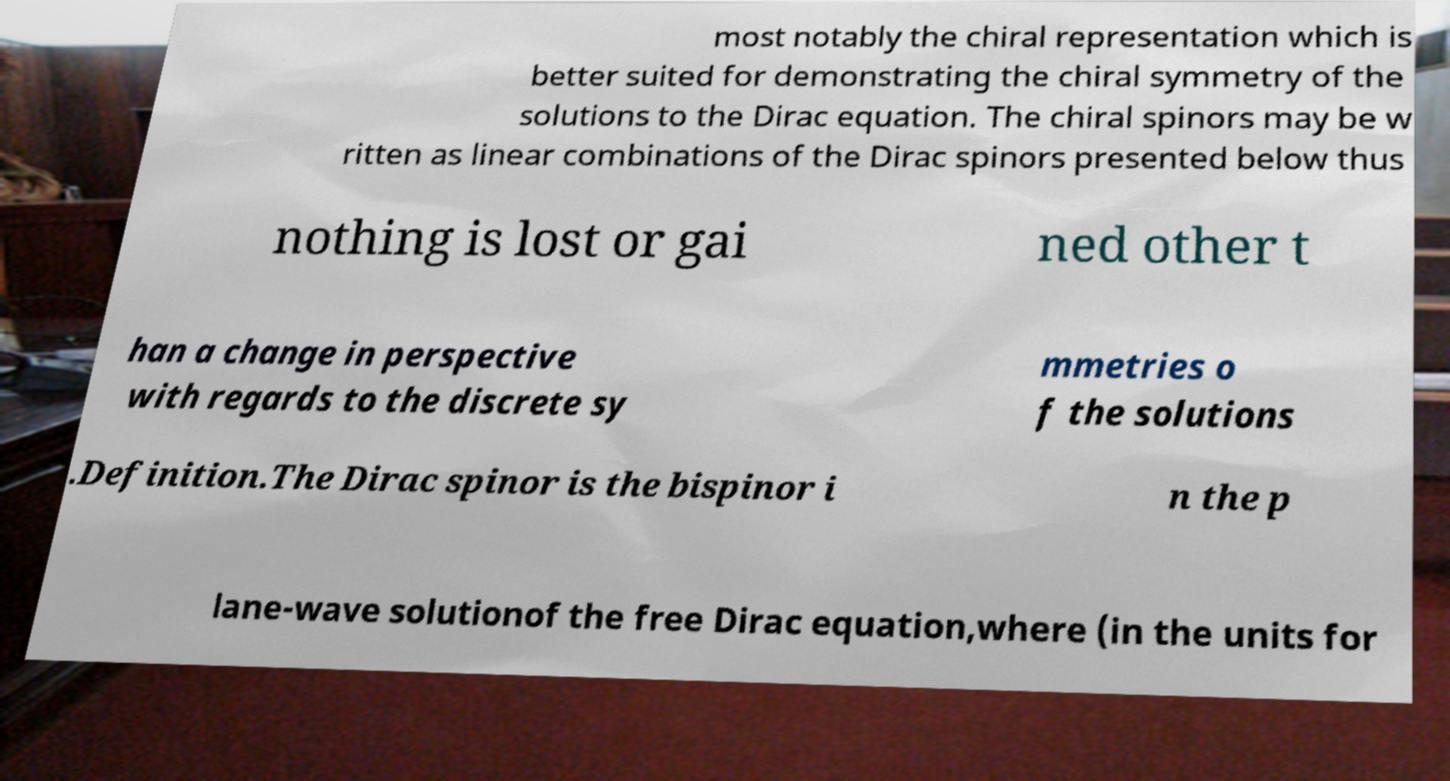Please read and relay the text visible in this image. What does it say? most notably the chiral representation which is better suited for demonstrating the chiral symmetry of the solutions to the Dirac equation. The chiral spinors may be w ritten as linear combinations of the Dirac spinors presented below thus nothing is lost or gai ned other t han a change in perspective with regards to the discrete sy mmetries o f the solutions .Definition.The Dirac spinor is the bispinor i n the p lane-wave solutionof the free Dirac equation,where (in the units for 